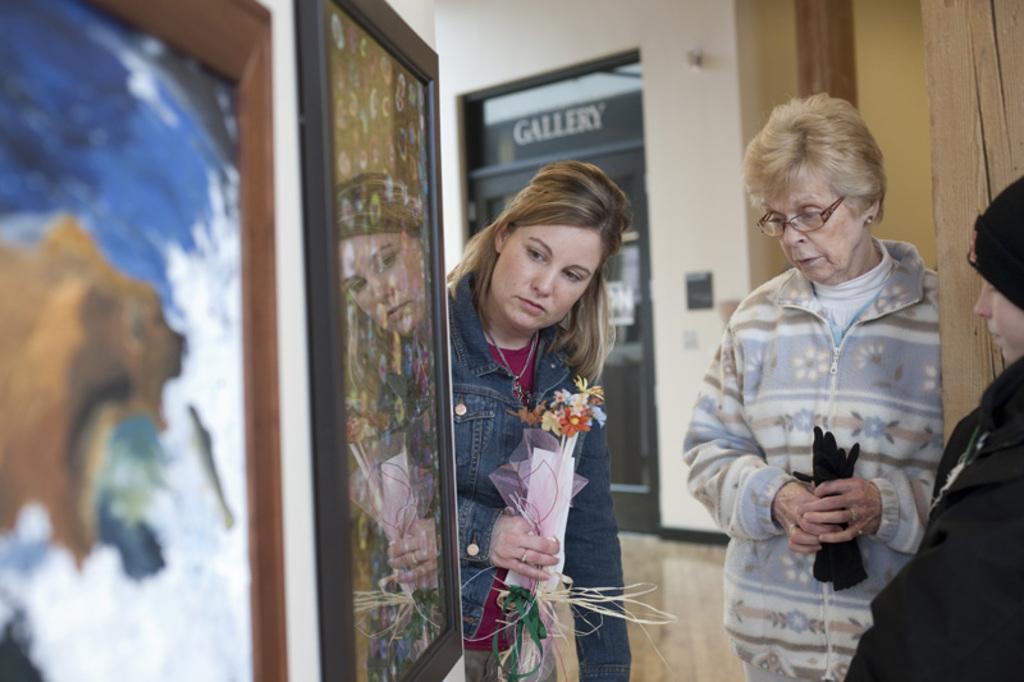Can you describe this image briefly? In his image we can see three woman are standing and watching to the frames which are attached to the wall. One woman is wearing black color dress, the other one is in white and blue color jacket holding gloves in her hand. The third one is wearing pink color t-shirt with jacket and holding flowers in her hand. Behind one door is there, on door ¨gallery" is written. 